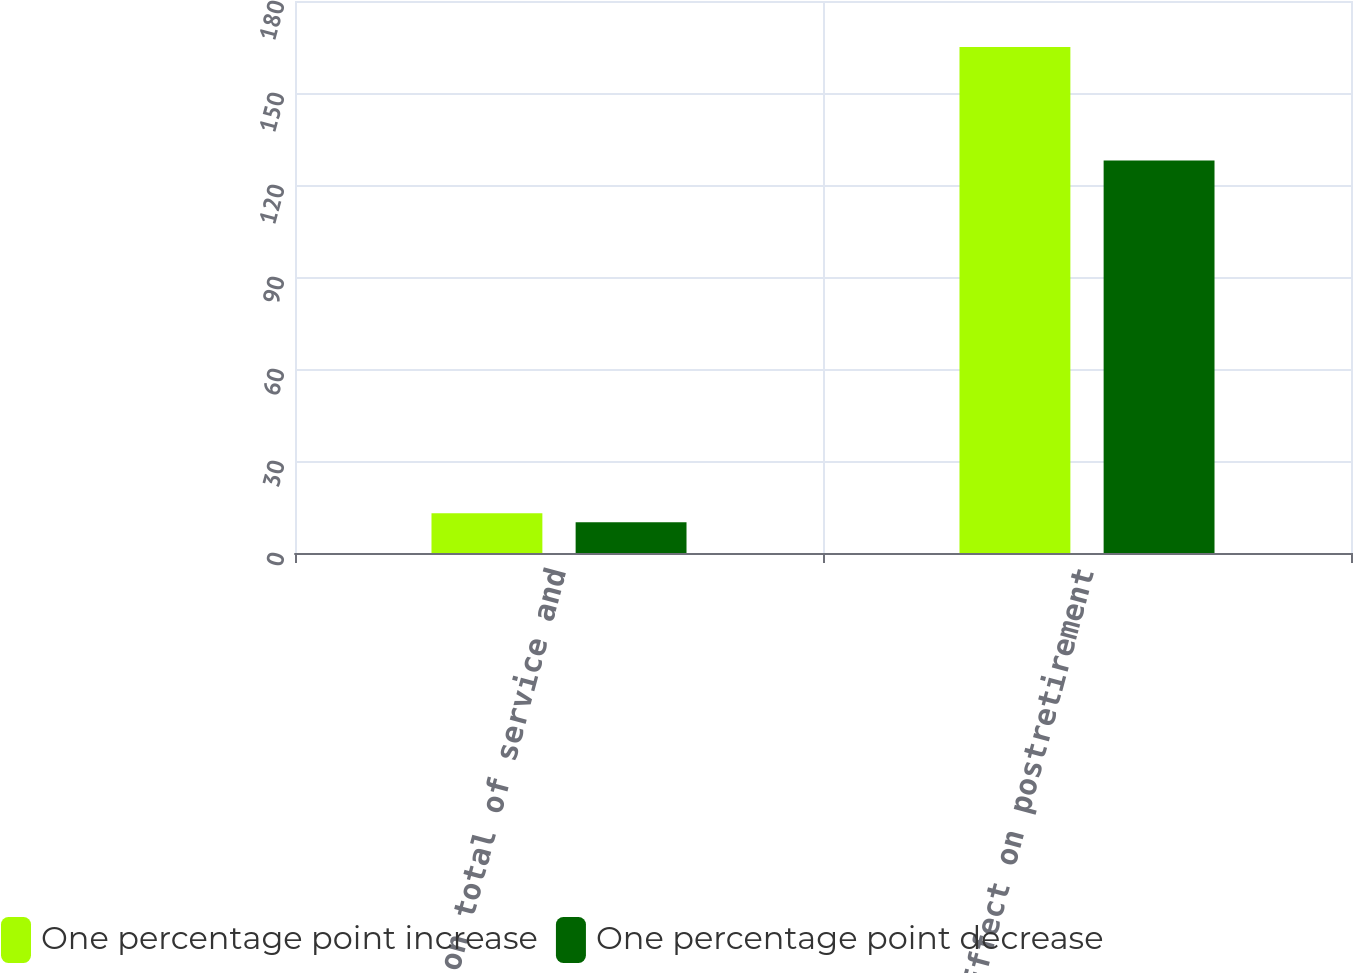Convert chart. <chart><loc_0><loc_0><loc_500><loc_500><stacked_bar_chart><ecel><fcel>Effect on total of service and<fcel>Effect on postretirement<nl><fcel>One percentage point increase<fcel>13<fcel>165<nl><fcel>One percentage point decrease<fcel>10<fcel>128<nl></chart> 